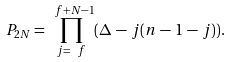Convert formula to latex. <formula><loc_0><loc_0><loc_500><loc_500>P _ { 2 N } = \prod _ { j = \ f } ^ { \ f + N - 1 } ( \Delta \, - \, j ( n \, - \, 1 \, - \, j ) ) .</formula> 